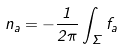<formula> <loc_0><loc_0><loc_500><loc_500>n _ { a } = - \frac { 1 } { 2 \pi } \int _ { \Sigma } f _ { a }</formula> 